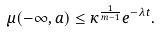Convert formula to latex. <formula><loc_0><loc_0><loc_500><loc_500>\mu ( - \infty , a ) \leq \kappa ^ { \frac { 1 } { m - 1 } } e ^ { - \lambda t } .</formula> 